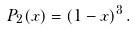Convert formula to latex. <formula><loc_0><loc_0><loc_500><loc_500>P _ { 2 } ( x ) = ( 1 - x ) ^ { 3 } \, .</formula> 